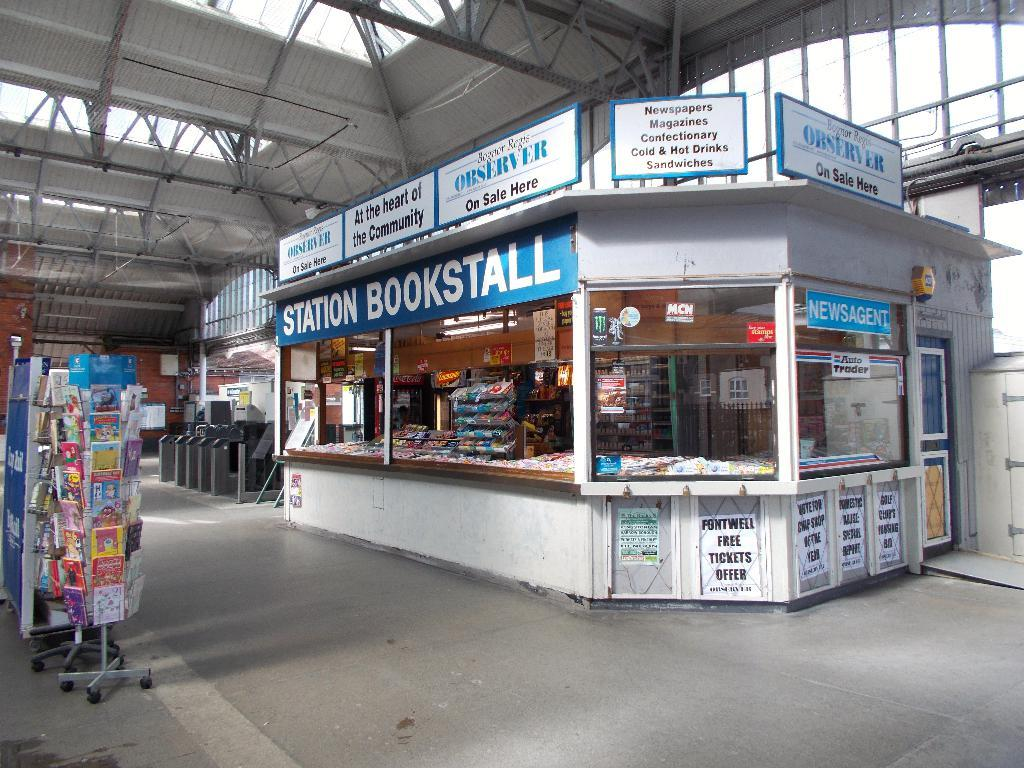<image>
Present a compact description of the photo's key features. The Station Bookstall sells many books and other items. 